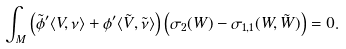Convert formula to latex. <formula><loc_0><loc_0><loc_500><loc_500>\int _ { M } \left ( \tilde { \phi } ^ { \prime } \langle V , \nu \rangle + \phi ^ { \prime } \langle \tilde { V } , \tilde { \nu } \rangle \right ) \left ( \sigma _ { 2 } ( W ) - \sigma _ { 1 , 1 } ( W , \tilde { W } ) \right ) = 0 .</formula> 